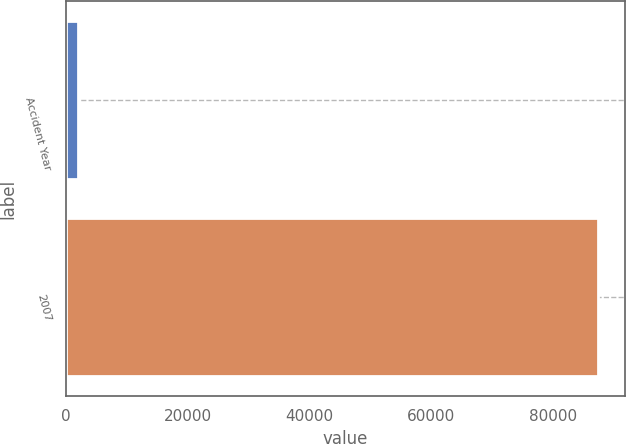<chart> <loc_0><loc_0><loc_500><loc_500><bar_chart><fcel>Accident Year<fcel>2007<nl><fcel>2016<fcel>87356<nl></chart> 